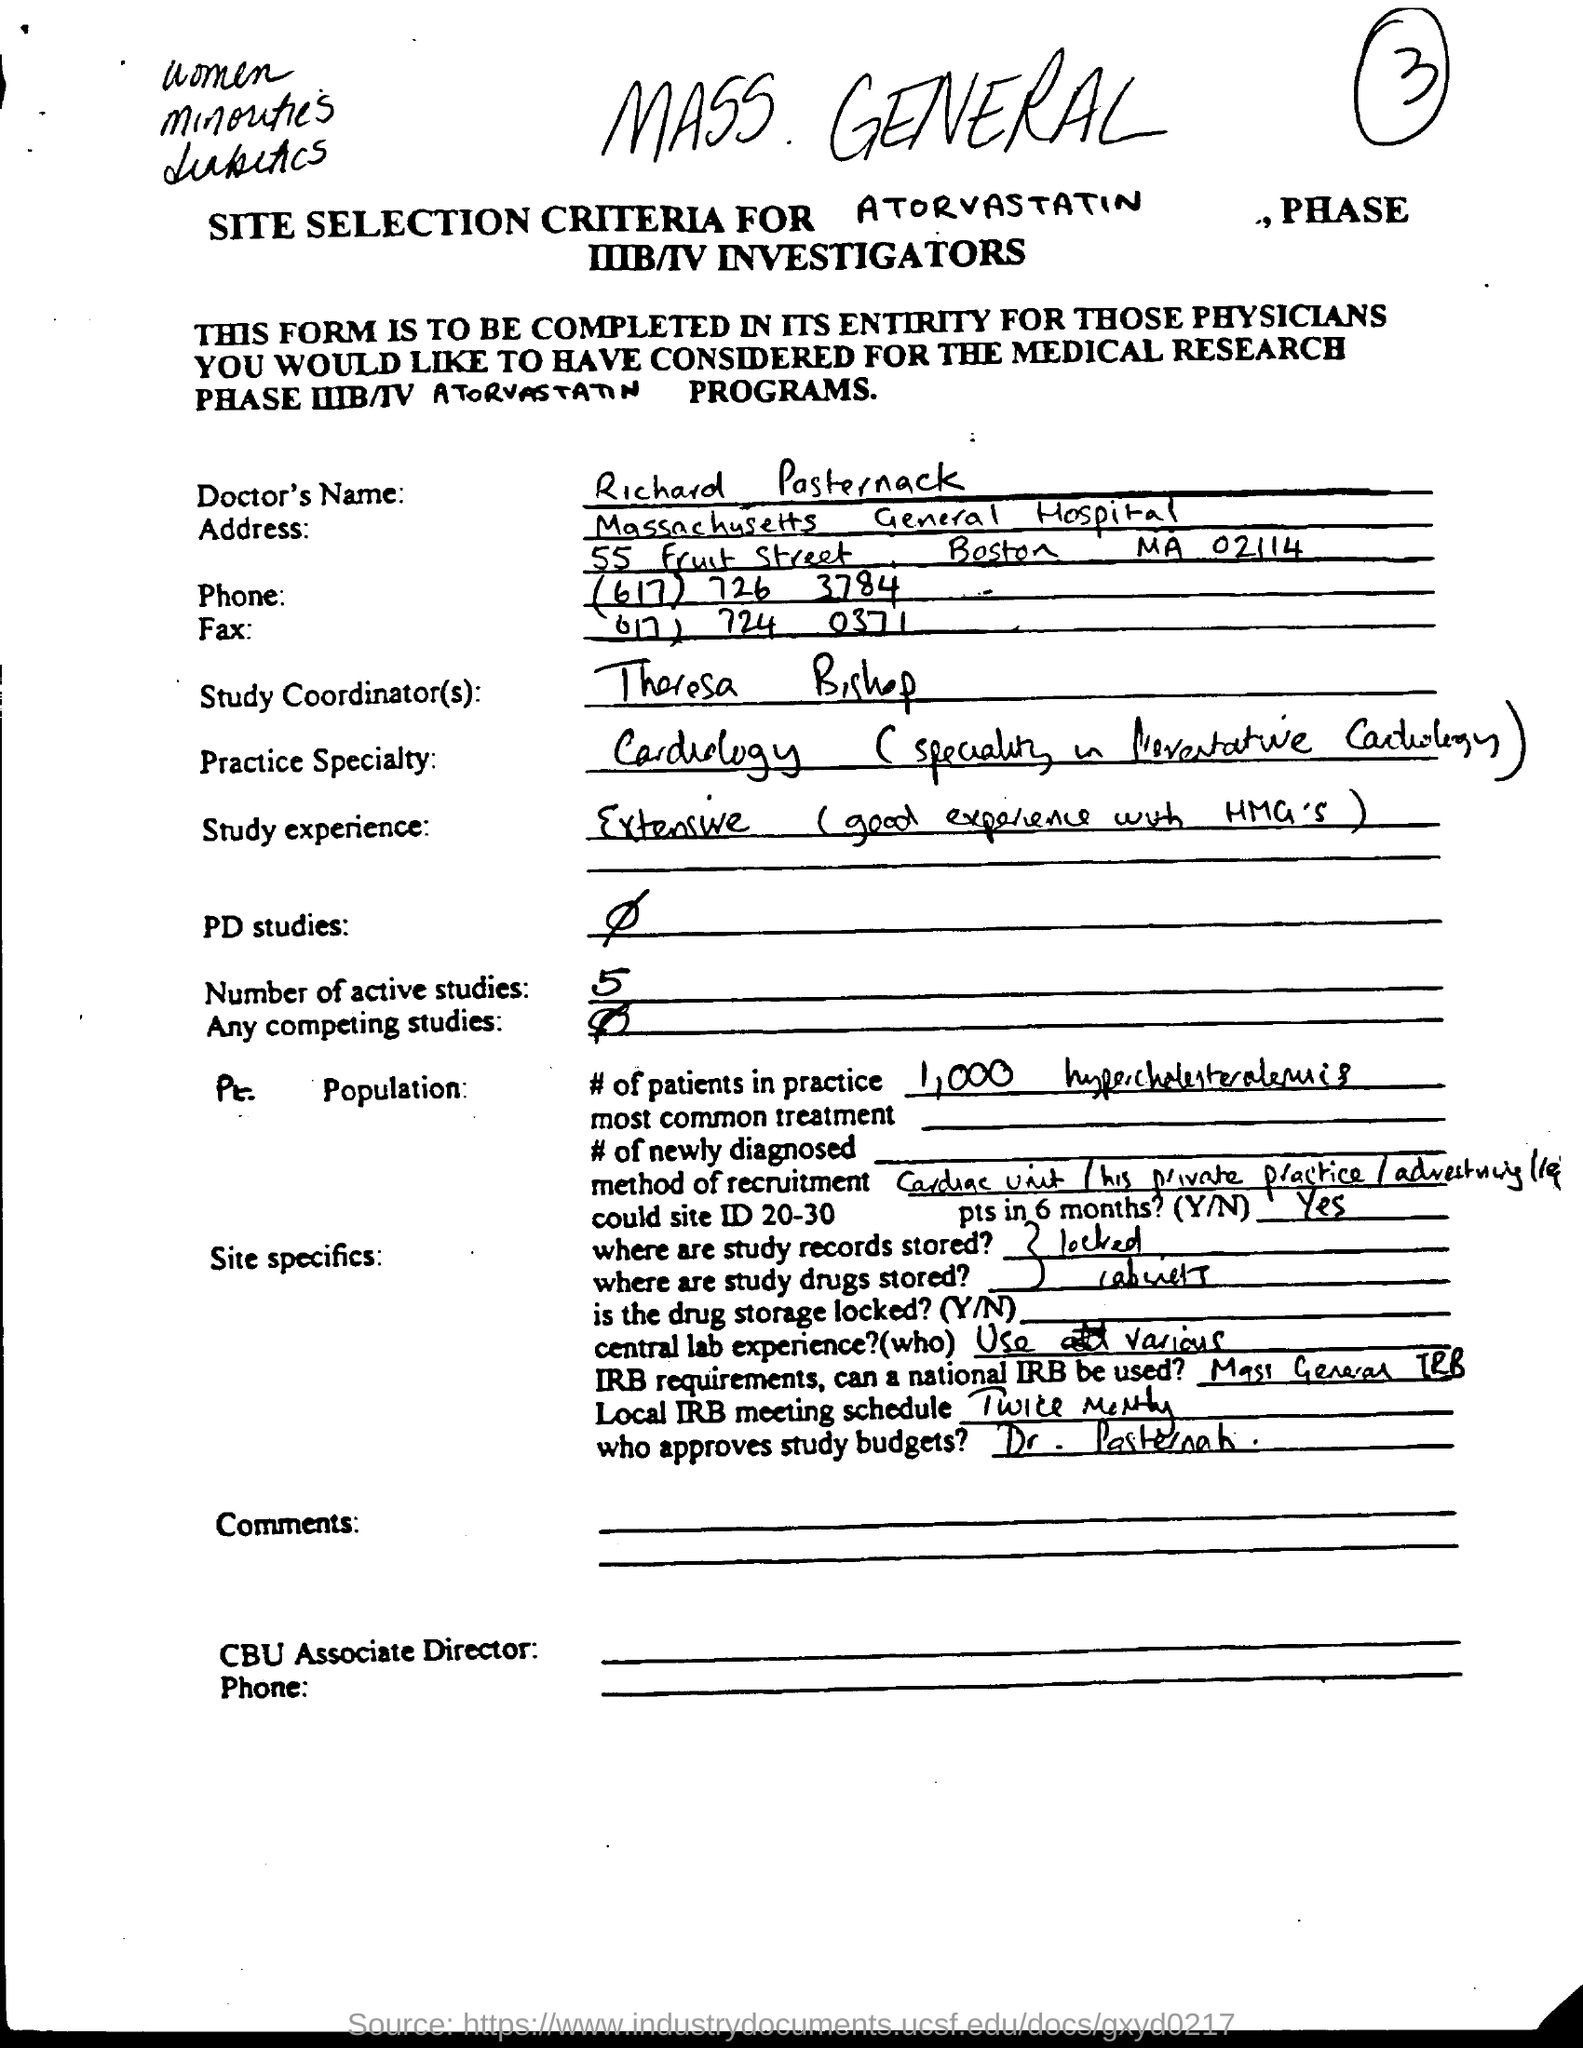Give some essential details in this illustration. There are currently five active studies underway. The Study Coordinator is Theresa Bishop. The Doctor's name is Richard Pasternack. 